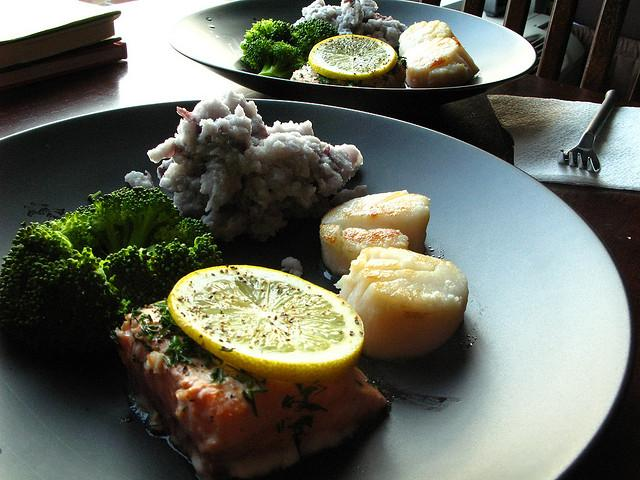Which food here is highest in vitamin B-12? salmon 